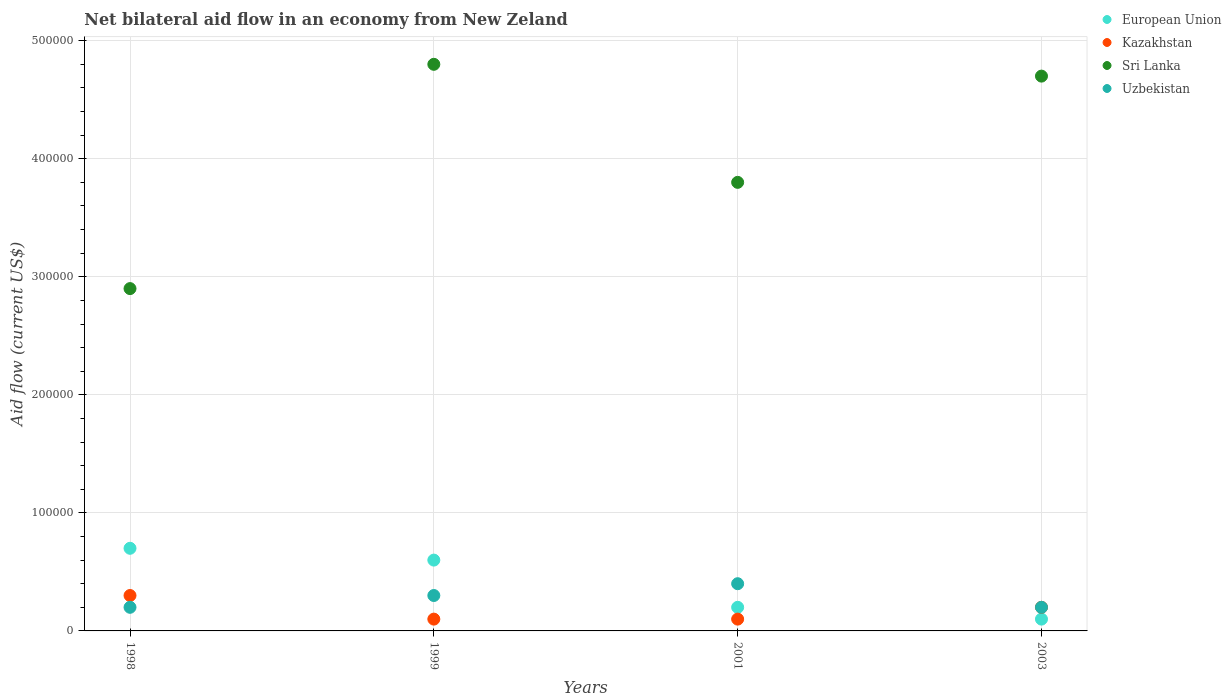How many different coloured dotlines are there?
Give a very brief answer. 4. In which year was the net bilateral aid flow in European Union maximum?
Give a very brief answer. 1998. In which year was the net bilateral aid flow in Uzbekistan minimum?
Your answer should be very brief. 1998. What is the total net bilateral aid flow in Sri Lanka in the graph?
Make the answer very short. 1.62e+06. What is the difference between the net bilateral aid flow in Sri Lanka in 1999 and that in 2001?
Offer a terse response. 1.00e+05. What is the difference between the net bilateral aid flow in Kazakhstan in 2003 and the net bilateral aid flow in European Union in 1999?
Offer a terse response. -4.00e+04. What is the average net bilateral aid flow in Sri Lanka per year?
Ensure brevity in your answer.  4.05e+05. What is the difference between the highest and the second highest net bilateral aid flow in Uzbekistan?
Your answer should be very brief. 10000. In how many years, is the net bilateral aid flow in Kazakhstan greater than the average net bilateral aid flow in Kazakhstan taken over all years?
Give a very brief answer. 2. Is the sum of the net bilateral aid flow in European Union in 1998 and 2001 greater than the maximum net bilateral aid flow in Uzbekistan across all years?
Keep it short and to the point. Yes. Is it the case that in every year, the sum of the net bilateral aid flow in Sri Lanka and net bilateral aid flow in Kazakhstan  is greater than the sum of net bilateral aid flow in European Union and net bilateral aid flow in Uzbekistan?
Your answer should be very brief. Yes. Is the net bilateral aid flow in European Union strictly greater than the net bilateral aid flow in Sri Lanka over the years?
Make the answer very short. No. How many years are there in the graph?
Provide a succinct answer. 4. Does the graph contain any zero values?
Your response must be concise. No. How are the legend labels stacked?
Give a very brief answer. Vertical. What is the title of the graph?
Your answer should be very brief. Net bilateral aid flow in an economy from New Zeland. What is the label or title of the Y-axis?
Provide a short and direct response. Aid flow (current US$). What is the Aid flow (current US$) in European Union in 1999?
Your response must be concise. 6.00e+04. What is the Aid flow (current US$) in Kazakhstan in 1999?
Offer a terse response. 10000. What is the Aid flow (current US$) of Uzbekistan in 1999?
Give a very brief answer. 3.00e+04. What is the Aid flow (current US$) of European Union in 2001?
Make the answer very short. 2.00e+04. What is the Aid flow (current US$) of European Union in 2003?
Give a very brief answer. 10000. What is the Aid flow (current US$) in Sri Lanka in 2003?
Provide a short and direct response. 4.70e+05. Across all years, what is the maximum Aid flow (current US$) of Sri Lanka?
Ensure brevity in your answer.  4.80e+05. Across all years, what is the minimum Aid flow (current US$) in Uzbekistan?
Your answer should be very brief. 2.00e+04. What is the total Aid flow (current US$) of Kazakhstan in the graph?
Provide a succinct answer. 7.00e+04. What is the total Aid flow (current US$) in Sri Lanka in the graph?
Your response must be concise. 1.62e+06. What is the difference between the Aid flow (current US$) in European Union in 1998 and that in 1999?
Offer a terse response. 10000. What is the difference between the Aid flow (current US$) in Uzbekistan in 1998 and that in 1999?
Offer a terse response. -10000. What is the difference between the Aid flow (current US$) of Kazakhstan in 1998 and that in 2003?
Ensure brevity in your answer.  10000. What is the difference between the Aid flow (current US$) in Sri Lanka in 1998 and that in 2003?
Your answer should be compact. -1.80e+05. What is the difference between the Aid flow (current US$) of Uzbekistan in 1998 and that in 2003?
Give a very brief answer. 0. What is the difference between the Aid flow (current US$) of European Union in 1999 and that in 2001?
Ensure brevity in your answer.  4.00e+04. What is the difference between the Aid flow (current US$) of Kazakhstan in 1999 and that in 2001?
Your answer should be very brief. 0. What is the difference between the Aid flow (current US$) in Uzbekistan in 1999 and that in 2001?
Your answer should be very brief. -10000. What is the difference between the Aid flow (current US$) of Kazakhstan in 1999 and that in 2003?
Keep it short and to the point. -10000. What is the difference between the Aid flow (current US$) in European Union in 2001 and that in 2003?
Provide a short and direct response. 10000. What is the difference between the Aid flow (current US$) of European Union in 1998 and the Aid flow (current US$) of Sri Lanka in 1999?
Make the answer very short. -4.10e+05. What is the difference between the Aid flow (current US$) in European Union in 1998 and the Aid flow (current US$) in Uzbekistan in 1999?
Give a very brief answer. 4.00e+04. What is the difference between the Aid flow (current US$) of Kazakhstan in 1998 and the Aid flow (current US$) of Sri Lanka in 1999?
Ensure brevity in your answer.  -4.50e+05. What is the difference between the Aid flow (current US$) of Sri Lanka in 1998 and the Aid flow (current US$) of Uzbekistan in 1999?
Your response must be concise. 2.60e+05. What is the difference between the Aid flow (current US$) in European Union in 1998 and the Aid flow (current US$) in Kazakhstan in 2001?
Offer a terse response. 6.00e+04. What is the difference between the Aid flow (current US$) in European Union in 1998 and the Aid flow (current US$) in Sri Lanka in 2001?
Keep it short and to the point. -3.10e+05. What is the difference between the Aid flow (current US$) of Kazakhstan in 1998 and the Aid flow (current US$) of Sri Lanka in 2001?
Give a very brief answer. -3.50e+05. What is the difference between the Aid flow (current US$) in Kazakhstan in 1998 and the Aid flow (current US$) in Uzbekistan in 2001?
Provide a short and direct response. -10000. What is the difference between the Aid flow (current US$) in Sri Lanka in 1998 and the Aid flow (current US$) in Uzbekistan in 2001?
Make the answer very short. 2.50e+05. What is the difference between the Aid flow (current US$) of European Union in 1998 and the Aid flow (current US$) of Kazakhstan in 2003?
Provide a short and direct response. 5.00e+04. What is the difference between the Aid flow (current US$) of European Union in 1998 and the Aid flow (current US$) of Sri Lanka in 2003?
Offer a very short reply. -4.00e+05. What is the difference between the Aid flow (current US$) in European Union in 1998 and the Aid flow (current US$) in Uzbekistan in 2003?
Offer a terse response. 5.00e+04. What is the difference between the Aid flow (current US$) in Kazakhstan in 1998 and the Aid flow (current US$) in Sri Lanka in 2003?
Ensure brevity in your answer.  -4.40e+05. What is the difference between the Aid flow (current US$) of Kazakhstan in 1998 and the Aid flow (current US$) of Uzbekistan in 2003?
Offer a very short reply. 10000. What is the difference between the Aid flow (current US$) of European Union in 1999 and the Aid flow (current US$) of Sri Lanka in 2001?
Provide a succinct answer. -3.20e+05. What is the difference between the Aid flow (current US$) in Kazakhstan in 1999 and the Aid flow (current US$) in Sri Lanka in 2001?
Ensure brevity in your answer.  -3.70e+05. What is the difference between the Aid flow (current US$) of European Union in 1999 and the Aid flow (current US$) of Kazakhstan in 2003?
Provide a succinct answer. 4.00e+04. What is the difference between the Aid flow (current US$) in European Union in 1999 and the Aid flow (current US$) in Sri Lanka in 2003?
Give a very brief answer. -4.10e+05. What is the difference between the Aid flow (current US$) of Kazakhstan in 1999 and the Aid flow (current US$) of Sri Lanka in 2003?
Give a very brief answer. -4.60e+05. What is the difference between the Aid flow (current US$) in European Union in 2001 and the Aid flow (current US$) in Kazakhstan in 2003?
Keep it short and to the point. 0. What is the difference between the Aid flow (current US$) in European Union in 2001 and the Aid flow (current US$) in Sri Lanka in 2003?
Offer a terse response. -4.50e+05. What is the difference between the Aid flow (current US$) of Kazakhstan in 2001 and the Aid flow (current US$) of Sri Lanka in 2003?
Ensure brevity in your answer.  -4.60e+05. What is the difference between the Aid flow (current US$) of Kazakhstan in 2001 and the Aid flow (current US$) of Uzbekistan in 2003?
Offer a very short reply. -10000. What is the difference between the Aid flow (current US$) in Sri Lanka in 2001 and the Aid flow (current US$) in Uzbekistan in 2003?
Your answer should be compact. 3.60e+05. What is the average Aid flow (current US$) in Kazakhstan per year?
Your response must be concise. 1.75e+04. What is the average Aid flow (current US$) in Sri Lanka per year?
Provide a succinct answer. 4.05e+05. What is the average Aid flow (current US$) in Uzbekistan per year?
Provide a short and direct response. 2.75e+04. In the year 1998, what is the difference between the Aid flow (current US$) in European Union and Aid flow (current US$) in Kazakhstan?
Your response must be concise. 4.00e+04. In the year 1998, what is the difference between the Aid flow (current US$) of European Union and Aid flow (current US$) of Uzbekistan?
Offer a very short reply. 5.00e+04. In the year 1999, what is the difference between the Aid flow (current US$) in European Union and Aid flow (current US$) in Sri Lanka?
Make the answer very short. -4.20e+05. In the year 1999, what is the difference between the Aid flow (current US$) in European Union and Aid flow (current US$) in Uzbekistan?
Offer a terse response. 3.00e+04. In the year 1999, what is the difference between the Aid flow (current US$) in Kazakhstan and Aid flow (current US$) in Sri Lanka?
Make the answer very short. -4.70e+05. In the year 2001, what is the difference between the Aid flow (current US$) in European Union and Aid flow (current US$) in Sri Lanka?
Make the answer very short. -3.60e+05. In the year 2001, what is the difference between the Aid flow (current US$) of Kazakhstan and Aid flow (current US$) of Sri Lanka?
Offer a terse response. -3.70e+05. In the year 2001, what is the difference between the Aid flow (current US$) of Sri Lanka and Aid flow (current US$) of Uzbekistan?
Offer a very short reply. 3.40e+05. In the year 2003, what is the difference between the Aid flow (current US$) in European Union and Aid flow (current US$) in Sri Lanka?
Your response must be concise. -4.60e+05. In the year 2003, what is the difference between the Aid flow (current US$) in Kazakhstan and Aid flow (current US$) in Sri Lanka?
Your response must be concise. -4.50e+05. What is the ratio of the Aid flow (current US$) in Kazakhstan in 1998 to that in 1999?
Give a very brief answer. 3. What is the ratio of the Aid flow (current US$) in Sri Lanka in 1998 to that in 1999?
Keep it short and to the point. 0.6. What is the ratio of the Aid flow (current US$) in European Union in 1998 to that in 2001?
Provide a short and direct response. 3.5. What is the ratio of the Aid flow (current US$) in Kazakhstan in 1998 to that in 2001?
Make the answer very short. 3. What is the ratio of the Aid flow (current US$) in Sri Lanka in 1998 to that in 2001?
Provide a succinct answer. 0.76. What is the ratio of the Aid flow (current US$) in Uzbekistan in 1998 to that in 2001?
Your answer should be compact. 0.5. What is the ratio of the Aid flow (current US$) in Kazakhstan in 1998 to that in 2003?
Make the answer very short. 1.5. What is the ratio of the Aid flow (current US$) of Sri Lanka in 1998 to that in 2003?
Keep it short and to the point. 0.62. What is the ratio of the Aid flow (current US$) in Uzbekistan in 1998 to that in 2003?
Keep it short and to the point. 1. What is the ratio of the Aid flow (current US$) of Kazakhstan in 1999 to that in 2001?
Your answer should be compact. 1. What is the ratio of the Aid flow (current US$) of Sri Lanka in 1999 to that in 2001?
Your answer should be very brief. 1.26. What is the ratio of the Aid flow (current US$) in Sri Lanka in 1999 to that in 2003?
Offer a terse response. 1.02. What is the ratio of the Aid flow (current US$) of Uzbekistan in 1999 to that in 2003?
Ensure brevity in your answer.  1.5. What is the ratio of the Aid flow (current US$) of European Union in 2001 to that in 2003?
Give a very brief answer. 2. What is the ratio of the Aid flow (current US$) of Kazakhstan in 2001 to that in 2003?
Your answer should be very brief. 0.5. What is the ratio of the Aid flow (current US$) of Sri Lanka in 2001 to that in 2003?
Provide a short and direct response. 0.81. What is the ratio of the Aid flow (current US$) of Uzbekistan in 2001 to that in 2003?
Make the answer very short. 2. What is the difference between the highest and the second highest Aid flow (current US$) in Kazakhstan?
Your answer should be very brief. 10000. What is the difference between the highest and the second highest Aid flow (current US$) of Sri Lanka?
Your answer should be very brief. 10000. What is the difference between the highest and the lowest Aid flow (current US$) in Kazakhstan?
Your answer should be compact. 2.00e+04. What is the difference between the highest and the lowest Aid flow (current US$) of Sri Lanka?
Your response must be concise. 1.90e+05. 